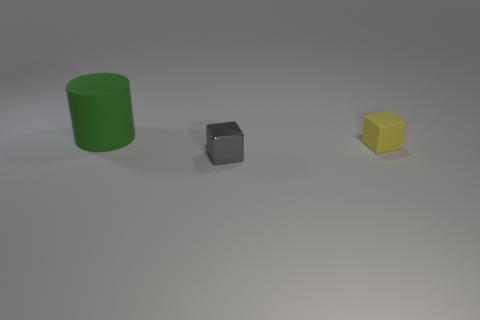Are there more yellow matte blocks behind the big green object than tiny matte things? Based on the image provided, there are no yellow matte blocks behind the big green object. In fact, there is only one yellow matte block visible, and it's located in front of the big green object rather than behind it. Furthermore, there are no tiny matte things present that could be compared in quantity to the yellow block. 